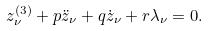Convert formula to latex. <formula><loc_0><loc_0><loc_500><loc_500>z _ { \nu } ^ { ( 3 ) } + p \ddot { z } _ { \nu } + q \dot { z } _ { \nu } + r \lambda _ { \nu } = 0 .</formula> 